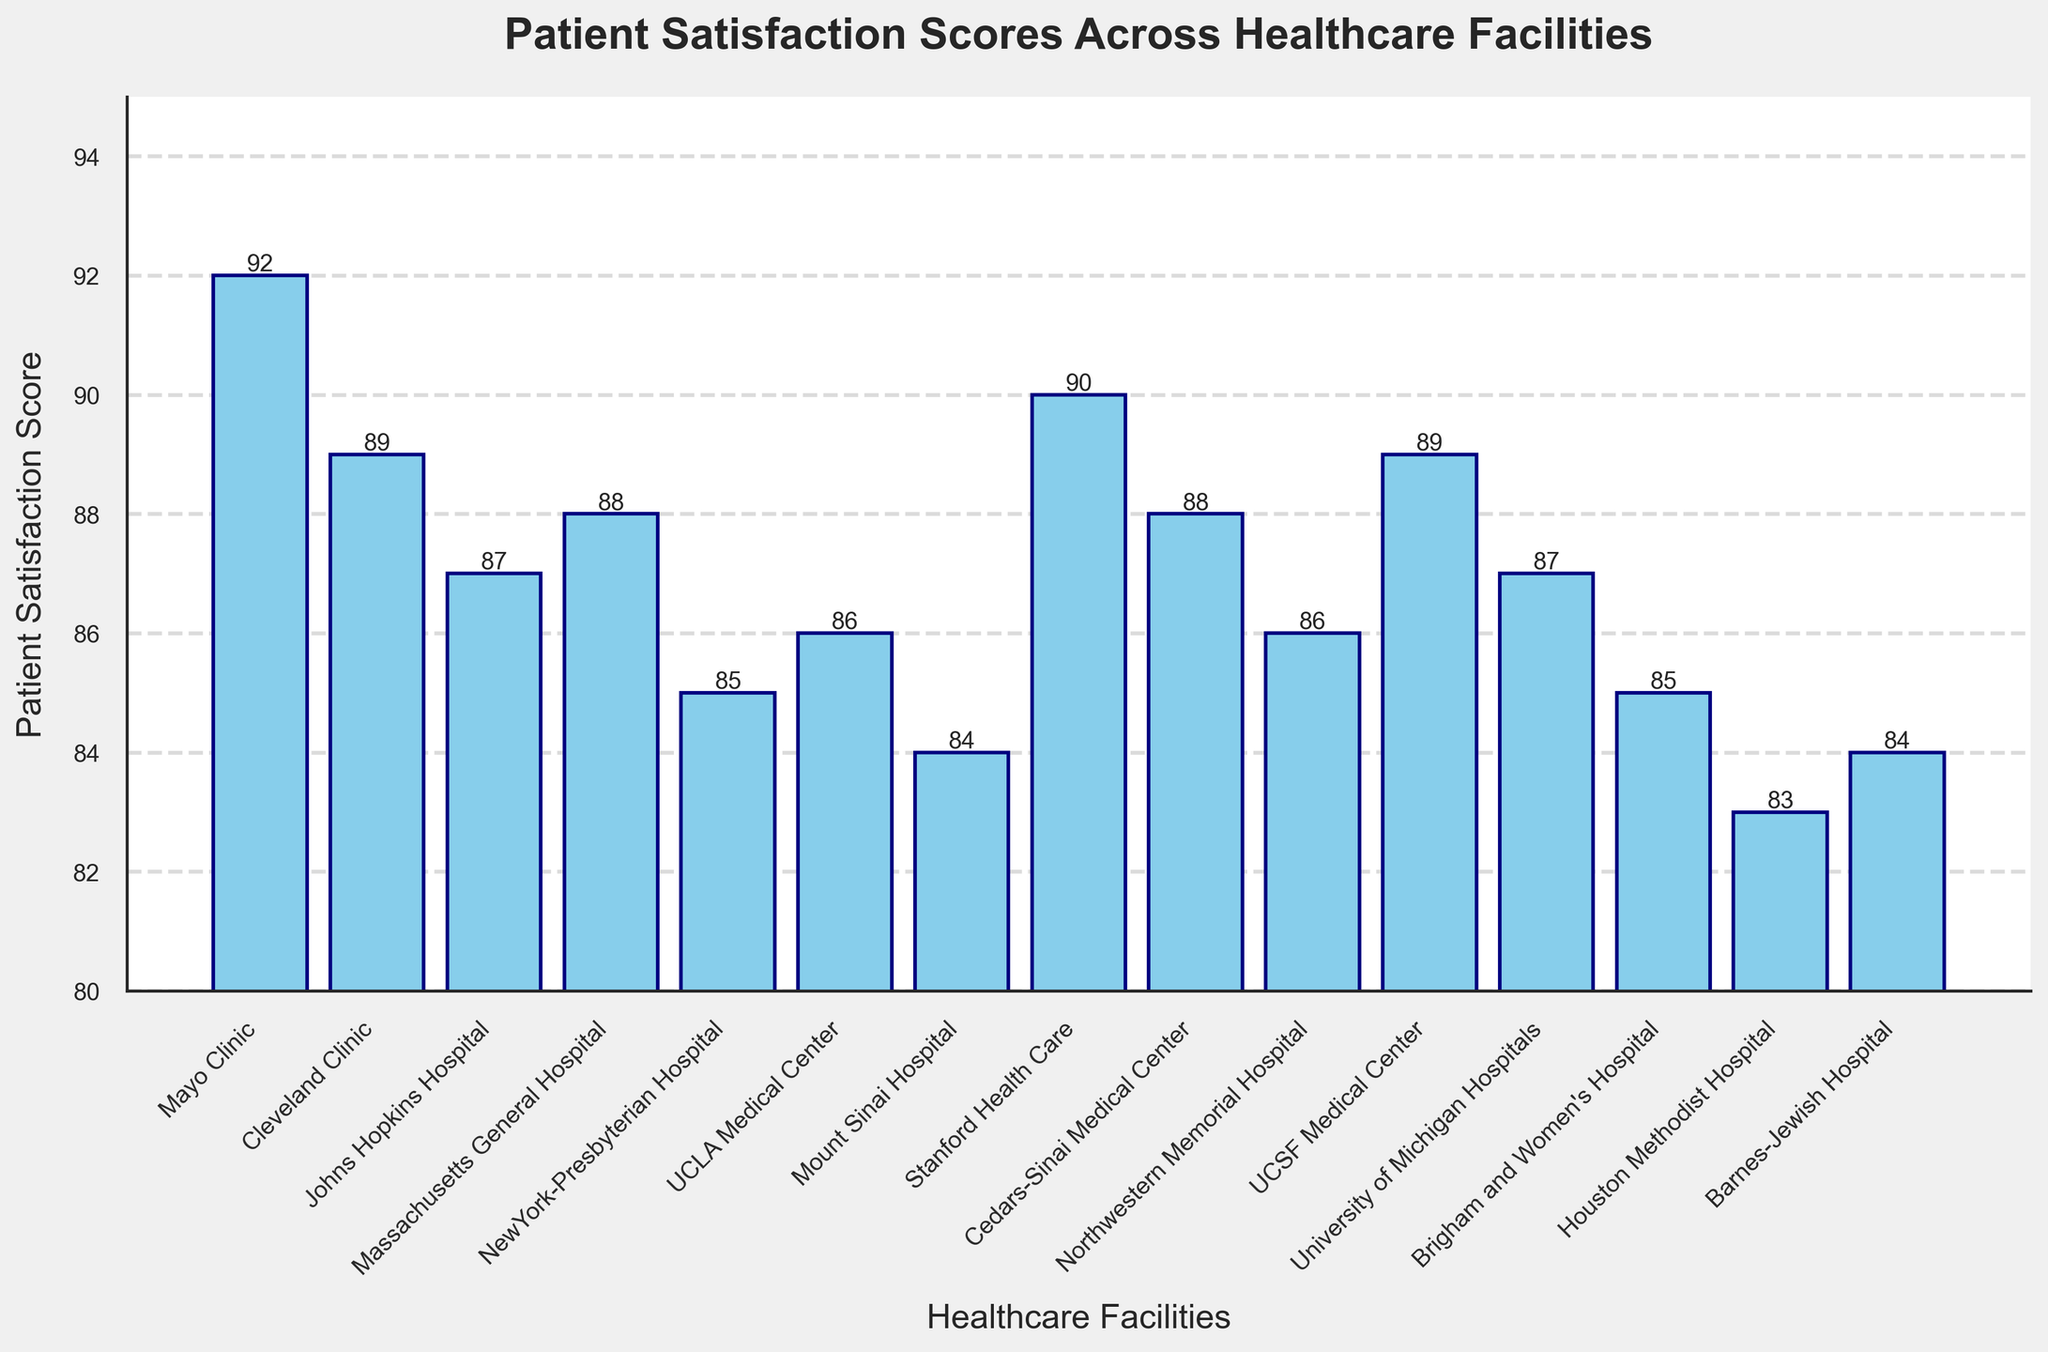What's the highest patient satisfaction score among the healthcare facilities? Look for the tallest bar in the chart. The highest bar represents the highest score, which is 92 for the Mayo Clinic.
Answer: 92 Which healthcare facility has the lowest patient satisfaction score? Identify the shortest bar in the chart. The shortest bar represents the lowest score, which is 83 for Houston Methodist Hospital.
Answer: Houston Methodist Hospital How many healthcare facilities have a patient satisfaction score of 87 or higher? Count the number of bars that reach or exceed the score of 87. They are Mayo Clinic (92), Cleveland Clinic (89), Johns Hopkins Hospital (87), Massachusetts General Hospital (88), Stanford Health Care (90), Cedars-Sinai Medical Center (88), and UCSF Medical Center (89). There are 7 in total.
Answer: 7 Which two healthcare facilities have the same patient satisfaction score, and what is the score? Identify the pairs of bars that have the exact same height. Both the Cleveland Clinic and UCSF Medical Center have a score of 89.
Answer: Cleveland Clinic and UCSF Medical Center, 89 What's the average patient satisfaction score across all healthcare facilities? Sum up all the satisfaction scores and divide by the number of facilities. The total sum is 1,279, and the number of facilities is 15. The average score is 1,279 / 15 = 85.27.
Answer: 85.27 Which three healthcare facilities have the most similar patient satisfaction scores? Determine the bars that are at similar heights. Look at the smallest differences between the heights. The scores for Northwestern Memorial Hospital (86), University of Michigan Hospitals (87), and UCLA Medical Center (86) are very close to each other.
Answer: Northwestern Memorial Hospital, University of Michigan Hospitals, and UCLA Medical Center What is the difference in patient satisfaction scores between Mayo Clinic and Houston Methodist Hospital? Find the difference between the scores for Mayo Clinic (92) and Houston Methodist Hospital (83). The difference is 92 - 83 = 9.
Answer: 9 What is the median patient satisfaction score of the healthcare facilities? Arrange the scores in ascending order and find the middle value. The scores in order are: 83, 84, 84, 85, 85, 86, 86, 87, 87, 88, 88, 89, 89, 90, 92. The middle value (8th score) is 87.
Answer: 87 How many healthcare facilities have a score lower than 85? Count the number of bars that are shorter than the bar representing the score of 85. They are Mount Sinai Hospital (84), Houston Methodist Hospital (83), and Barnes-Jewish Hospital (84). There are 3 in total.
Answer: 3 Which healthcare facility falls in the middle in terms of patient satisfaction score? Arrange all facilities in order based on their scores, and identify the one in the middle position. The middle facility in terms of score is University of Michigan Hospitals (87), which has the 8th highest score in an ordered list.
Answer: University of Michigan Hospitals 